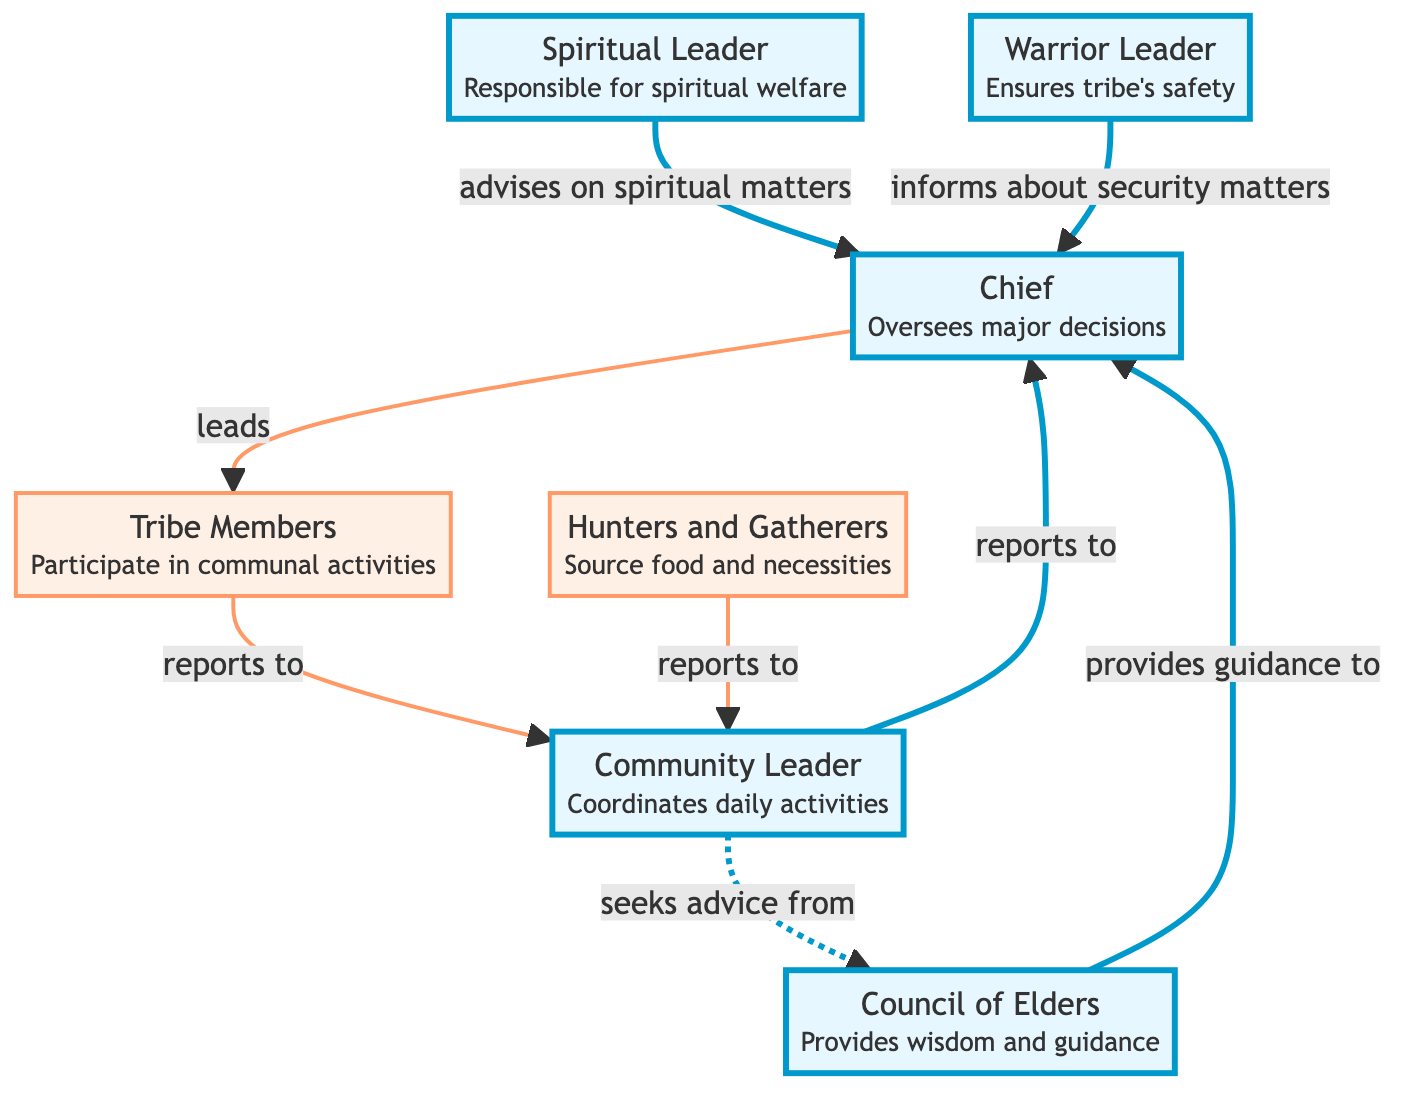What is the main role of the Chief? The main role of the Chief is to oversee major decisions affecting the tribe. This is indicated by the description attached to the Chief node in the diagram.
Answer: Oversees major decisions How many leadership roles are shown in this diagram? By counting the distinct leadership roles in the diagram, which include the Chief, Council of Elders, Spiritual Leader, Warrior Leader, and Community Leader, we can determine that there are five.
Answer: 5 Who advises the Chief on spiritual matters? The diagram shows that the Spiritual Leader is the one who advises the Chief on issues related to spiritual welfare. This relationship is explicitly stated in the directed link pointing from the Spiritual Leader to the Chief.
Answer: Spiritual Leader Which group coordinates daily activities? The Community Leader is identified in the diagram as the one who coordinates the daily activities within the tribe, as indicated in the description beside the Community Leader node.
Answer: Community Leader What do the Hunters and Gatherers report to? The Hunters and Gatherers are shown to report to the Community Leader in the diagram, as denoted by the directed edge connecting them to the Community Leader node.
Answer: Community Leader Who provides guidance to the Chief? The Council of Elders provides guidance to the Chief, which is represented by the directed link from the Council of Elders to the Chief node in the diagram.
Answer: Council of Elders What is the relationship between the Community Leader and the Chief? The diagram shows a direct relationship where the Community Leader reports to the Chief, indicating a supervisory or hierarchical connection between the two roles.
Answer: Reports to How many types of leaders are shown in the diagram? The diagram categorizes leaders into two types: those in leadership roles (like Chief, Council of Elders, etc.) and the Tribe Members who carry out communal responsibilities. There are five leaders specifically identified.
Answer: 5 leaders 